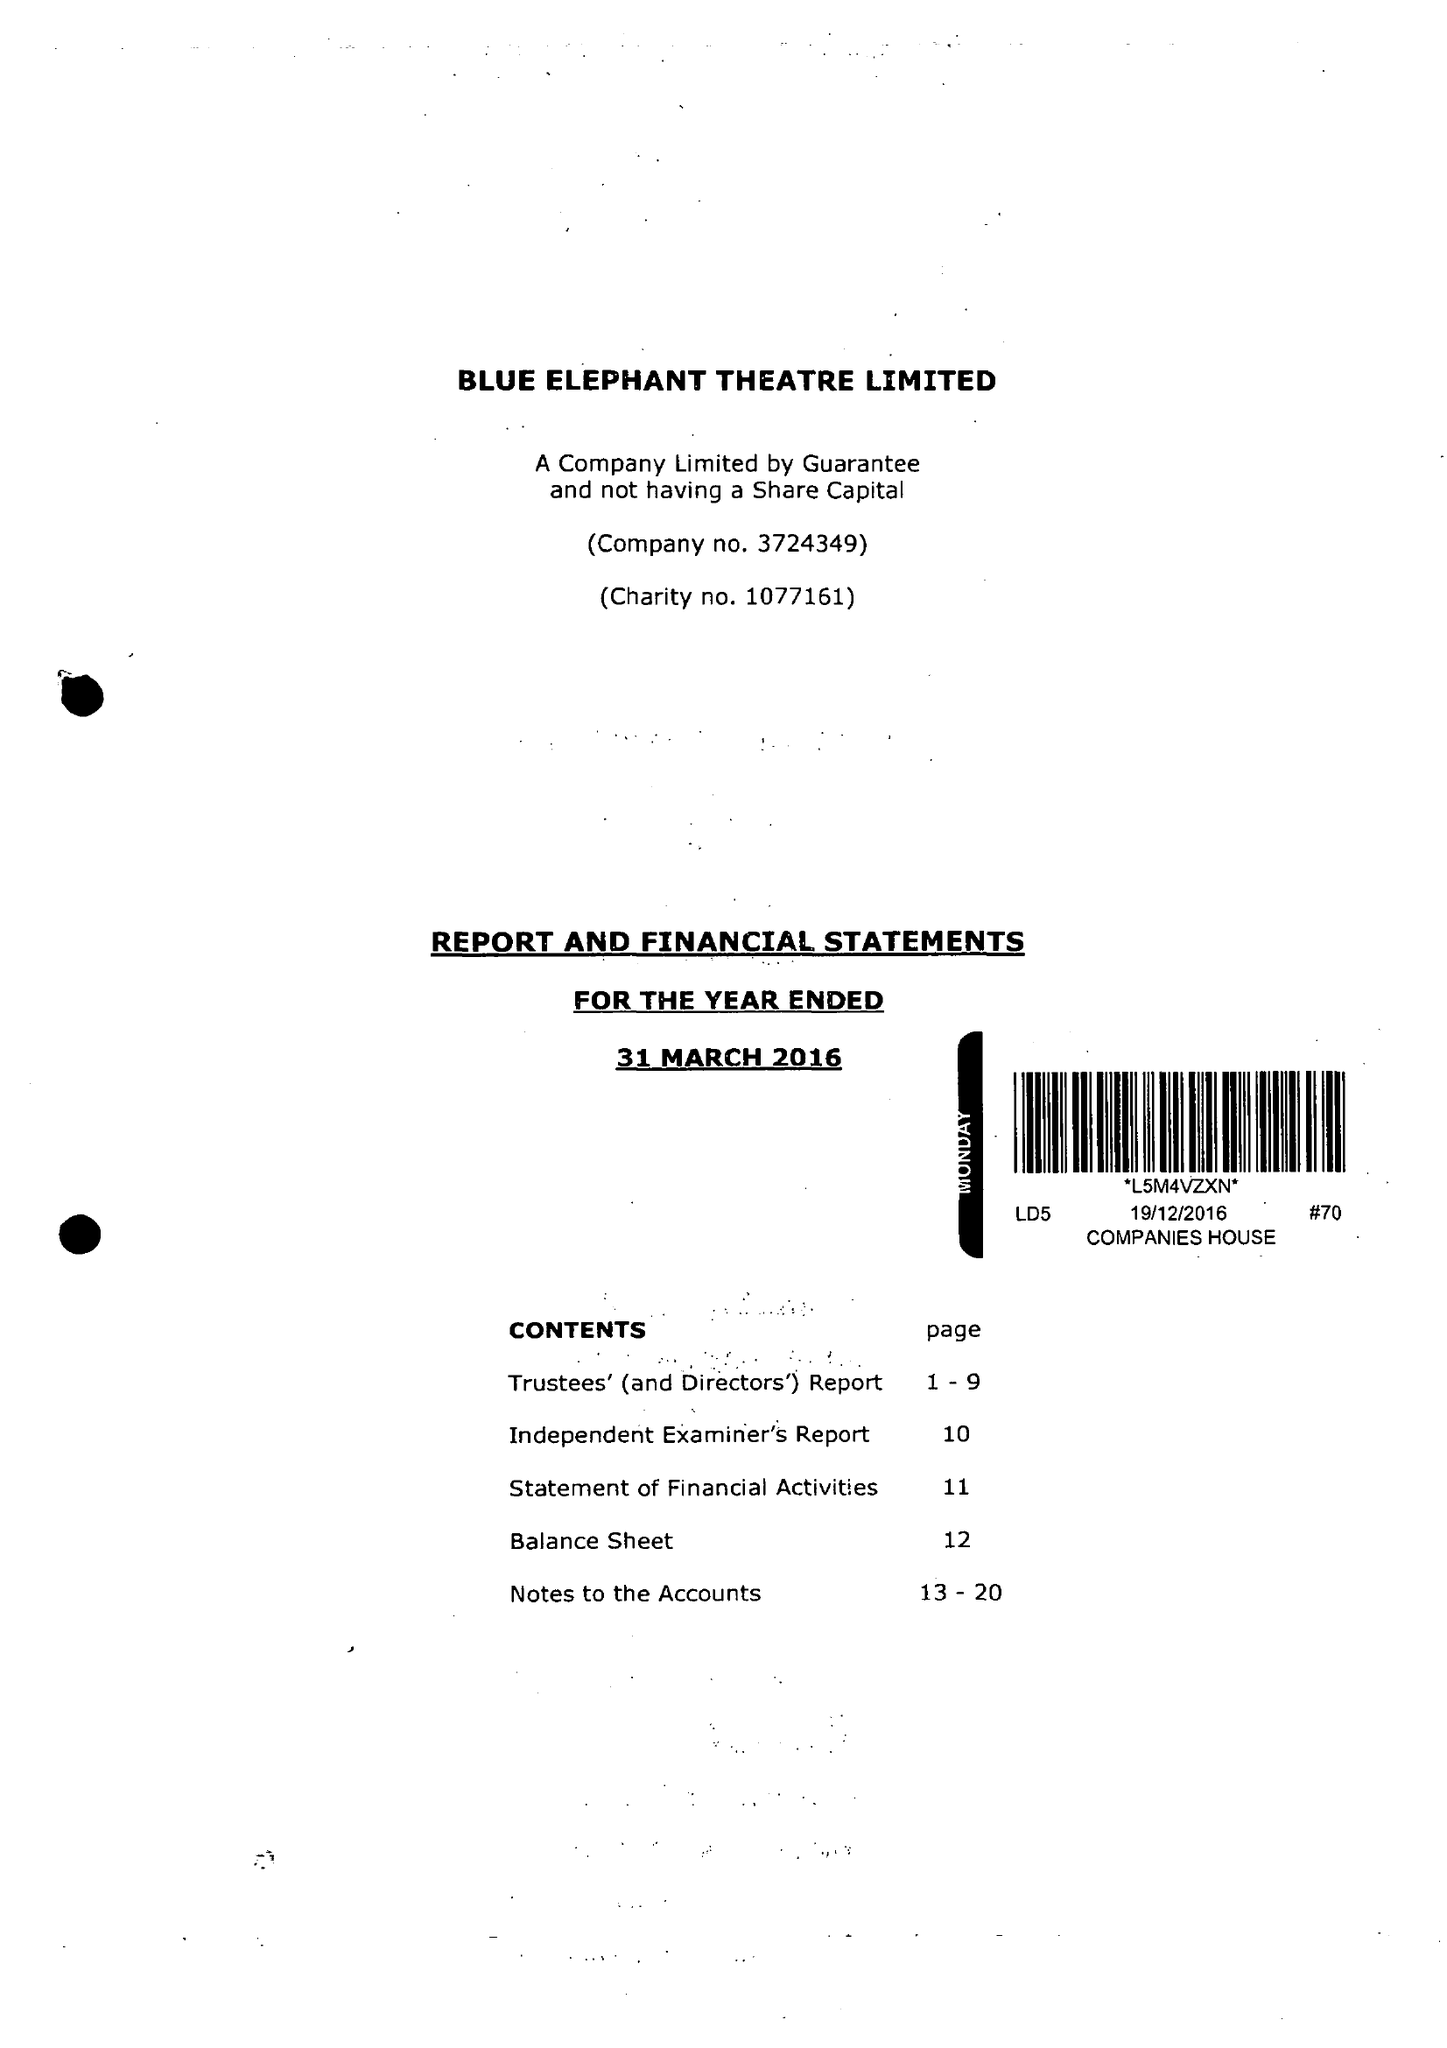What is the value for the address__postcode?
Answer the question using a single word or phrase. SE5 0XT 